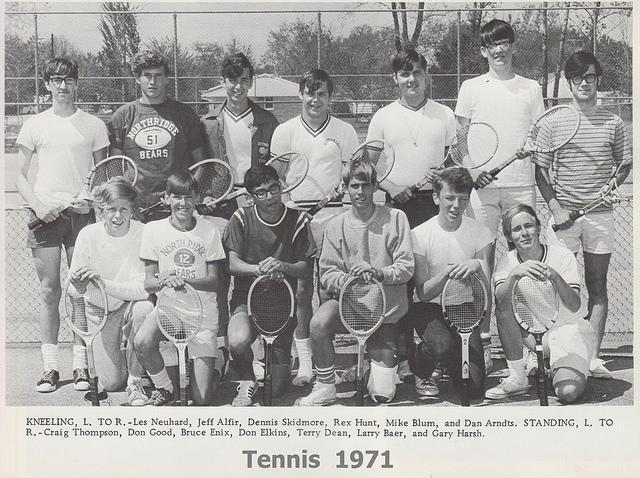How many tennis rackets are there?
Give a very brief answer. 3. How many people are there?
Give a very brief answer. 13. 